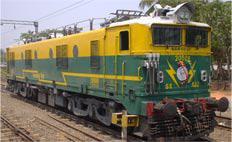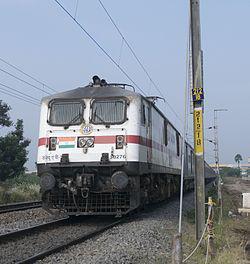The first image is the image on the left, the second image is the image on the right. Examine the images to the left and right. Is the description "A green train, with yellow trim and two square end windows, is sitting on the tracks on a sunny day." accurate? Answer yes or no. Yes. 